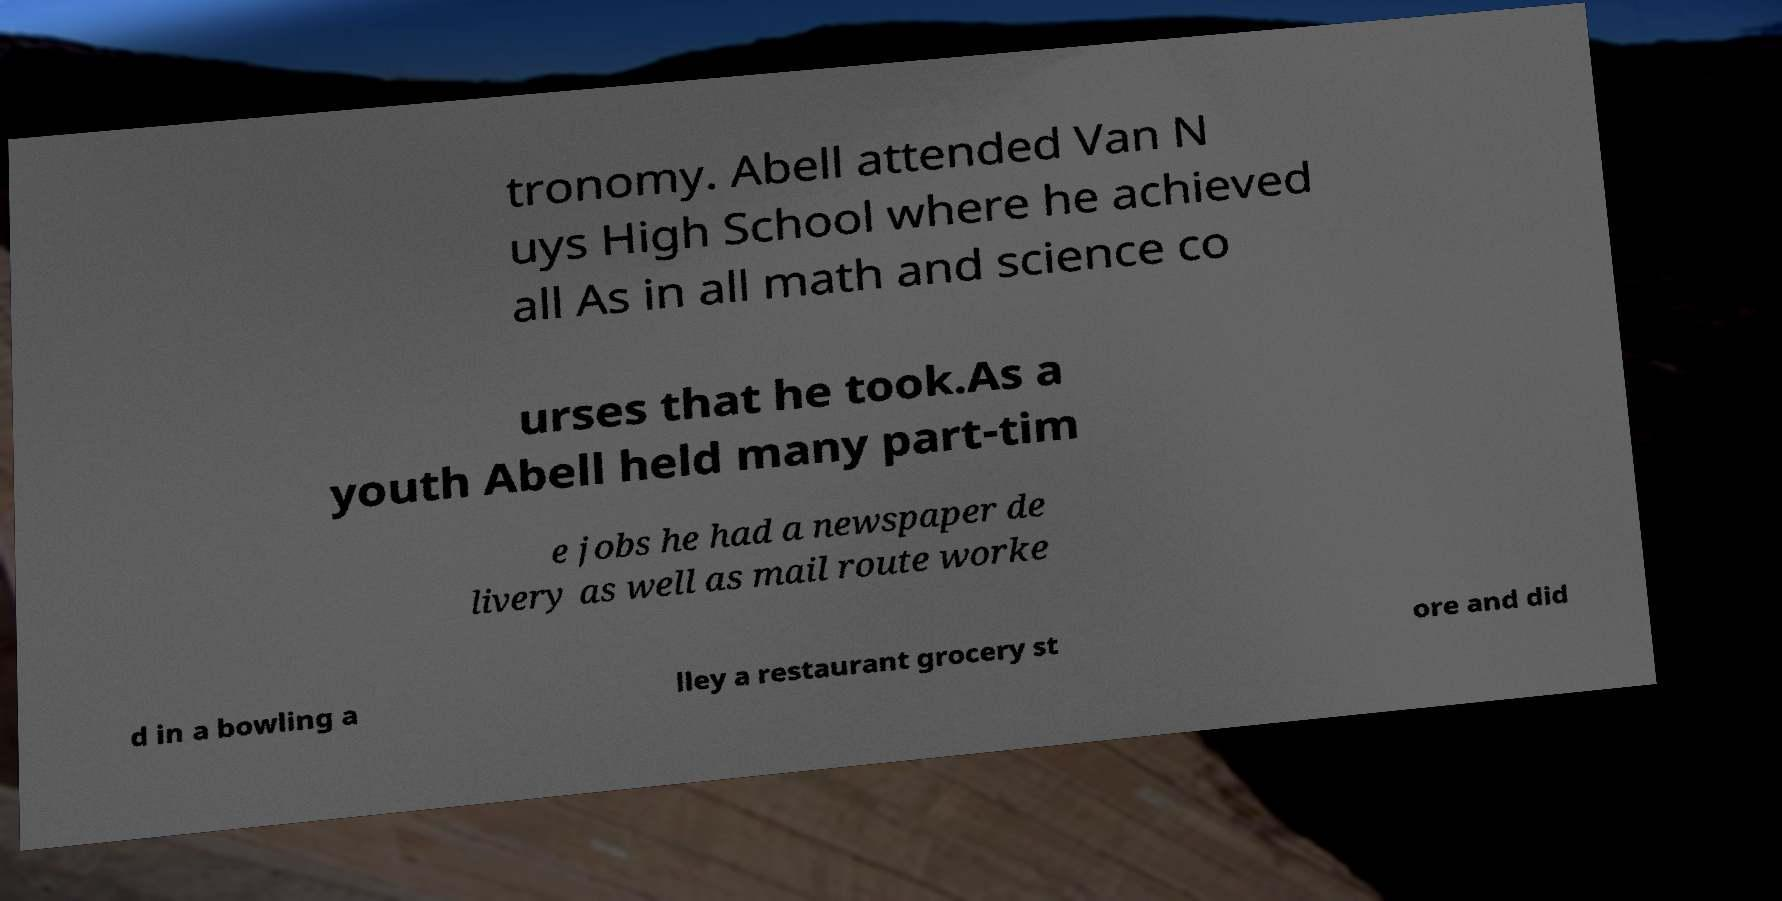Can you accurately transcribe the text from the provided image for me? tronomy. Abell attended Van N uys High School where he achieved all As in all math and science co urses that he took.As a youth Abell held many part-tim e jobs he had a newspaper de livery as well as mail route worke d in a bowling a lley a restaurant grocery st ore and did 